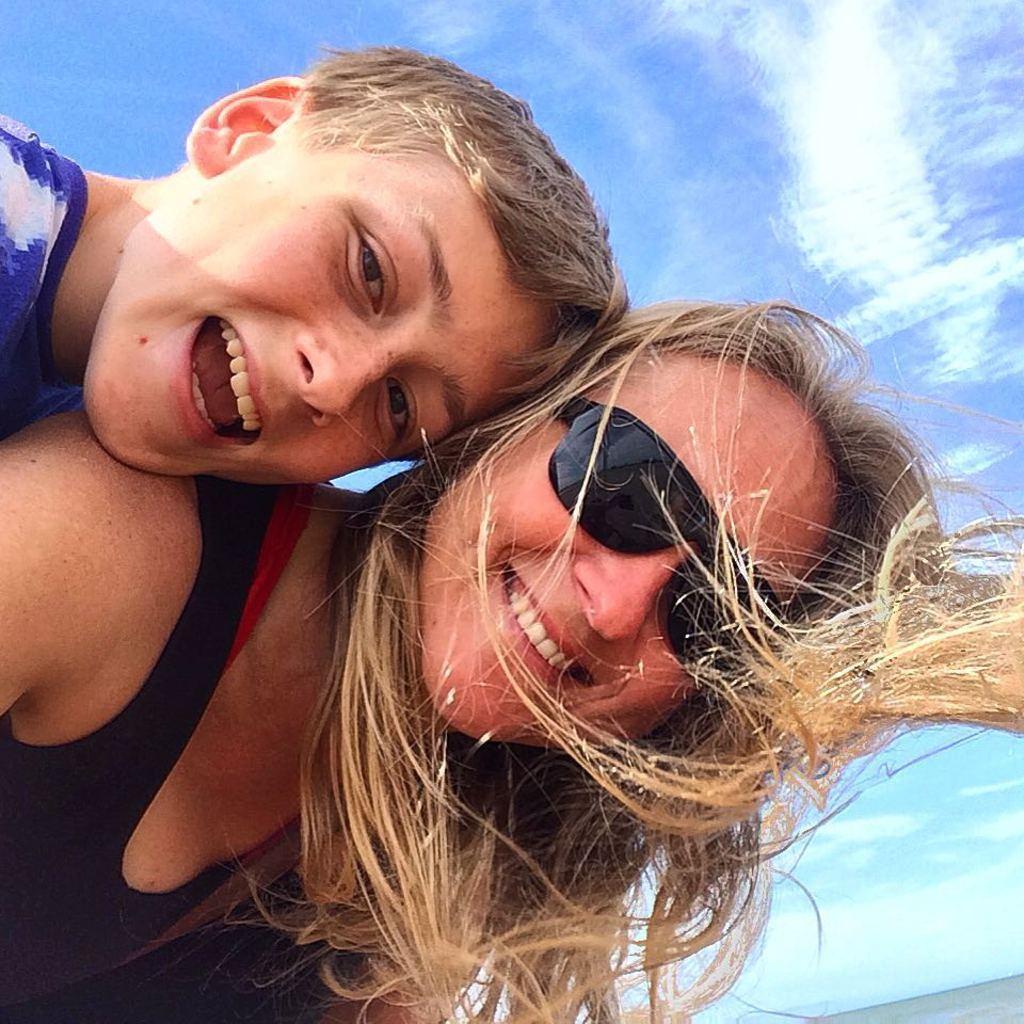Please provide a concise description of this image. In this image there is a woman boy smiling behind him there are clouds in the sky. 